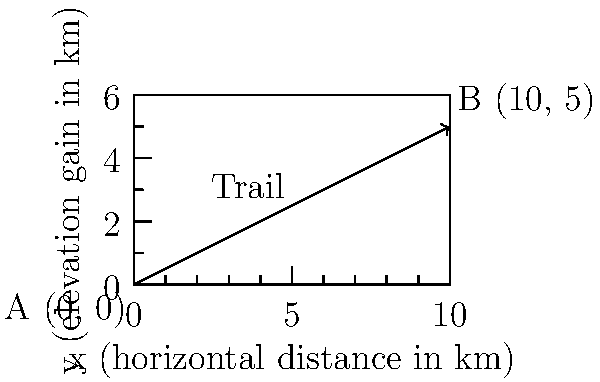As an experienced backpacker, you're planning a challenging route through a mountainous region. The topographic map shows a steep trail segment starting at point A (0, 0) and ending at point B (10, 5), where the coordinates represent horizontal distance and elevation gain in kilometers, respectively. Using the slope formula, calculate the angle of inclination (in degrees) for this trail segment. Round your answer to the nearest degree. To solve this problem, we'll follow these steps:

1) First, let's recall the slope formula:
   $m = \frac{y_2 - y_1}{x_2 - x_1}$

2) We can identify the points from the given information:
   A $(x_1, y_1) = (0, 0)$
   B $(x_2, y_2) = (10, 5)$

3) Let's plug these into the slope formula:
   $m = \frac{5 - 0}{10 - 0} = \frac{5}{10} = 0.5$

4) Now, we need to convert this slope to an angle. We can use the arctangent function for this:
   $\theta = \arctan(m)$

5) Plugging in our slope:
   $\theta = \arctan(0.5)$

6) Using a calculator or computer:
   $\theta \approx 0.4636$ radians

7) To convert radians to degrees, we multiply by $\frac{180}{\pi}$:
   $\theta \approx 0.4636 \times \frac{180}{\pi} \approx 26.57°$

8) Rounding to the nearest degree:
   $\theta \approx 27°$

Therefore, the angle of inclination for this trail segment is approximately 27 degrees.
Answer: 27° 